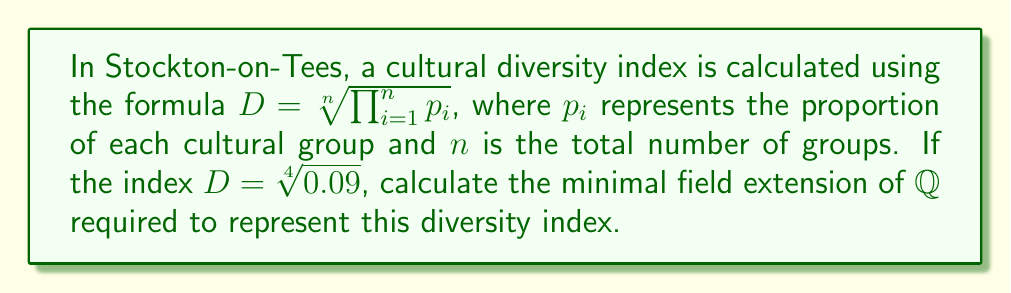Could you help me with this problem? To determine the minimal field extension required to represent the diversity index, we need to follow these steps:

1) First, simplify the given expression:
   $D = \sqrt[4]{0.09} = \sqrt[4]{\frac{9}{100}} = \frac{\sqrt[4]{9}}{(\sqrt[4]{100})}$

2) Simplify further:
   $D = \frac{\sqrt[4]{9}}{\sqrt{10}} = \frac{3^{\frac{1}{4}}}{\sqrt{10}}$

3) The expression now contains two irrational numbers: $3^{\frac{1}{4}}$ and $\sqrt{10}$

4) To represent $3^{\frac{1}{4}}$, we need a field extension of degree 4 over $\mathbb{Q}$, as it's the fourth root of a rational number.

5) To represent $\sqrt{10}$, we need a field extension of degree 2 over $\mathbb{Q}$.

6) The minimal field that contains both of these elements is the compositum of $\mathbb{Q}(3^{\frac{1}{4}})$ and $\mathbb{Q}(\sqrt{10})$.

7) The degree of this compositum over $\mathbb{Q}$ is the least common multiple of 4 and 2, which is 4.

Therefore, the minimal field extension required is of degree 4 over $\mathbb{Q}$.
Answer: $[\mathbb{Q}(3^{\frac{1}{4}}, \sqrt{10}) : \mathbb{Q}] = 4$ 